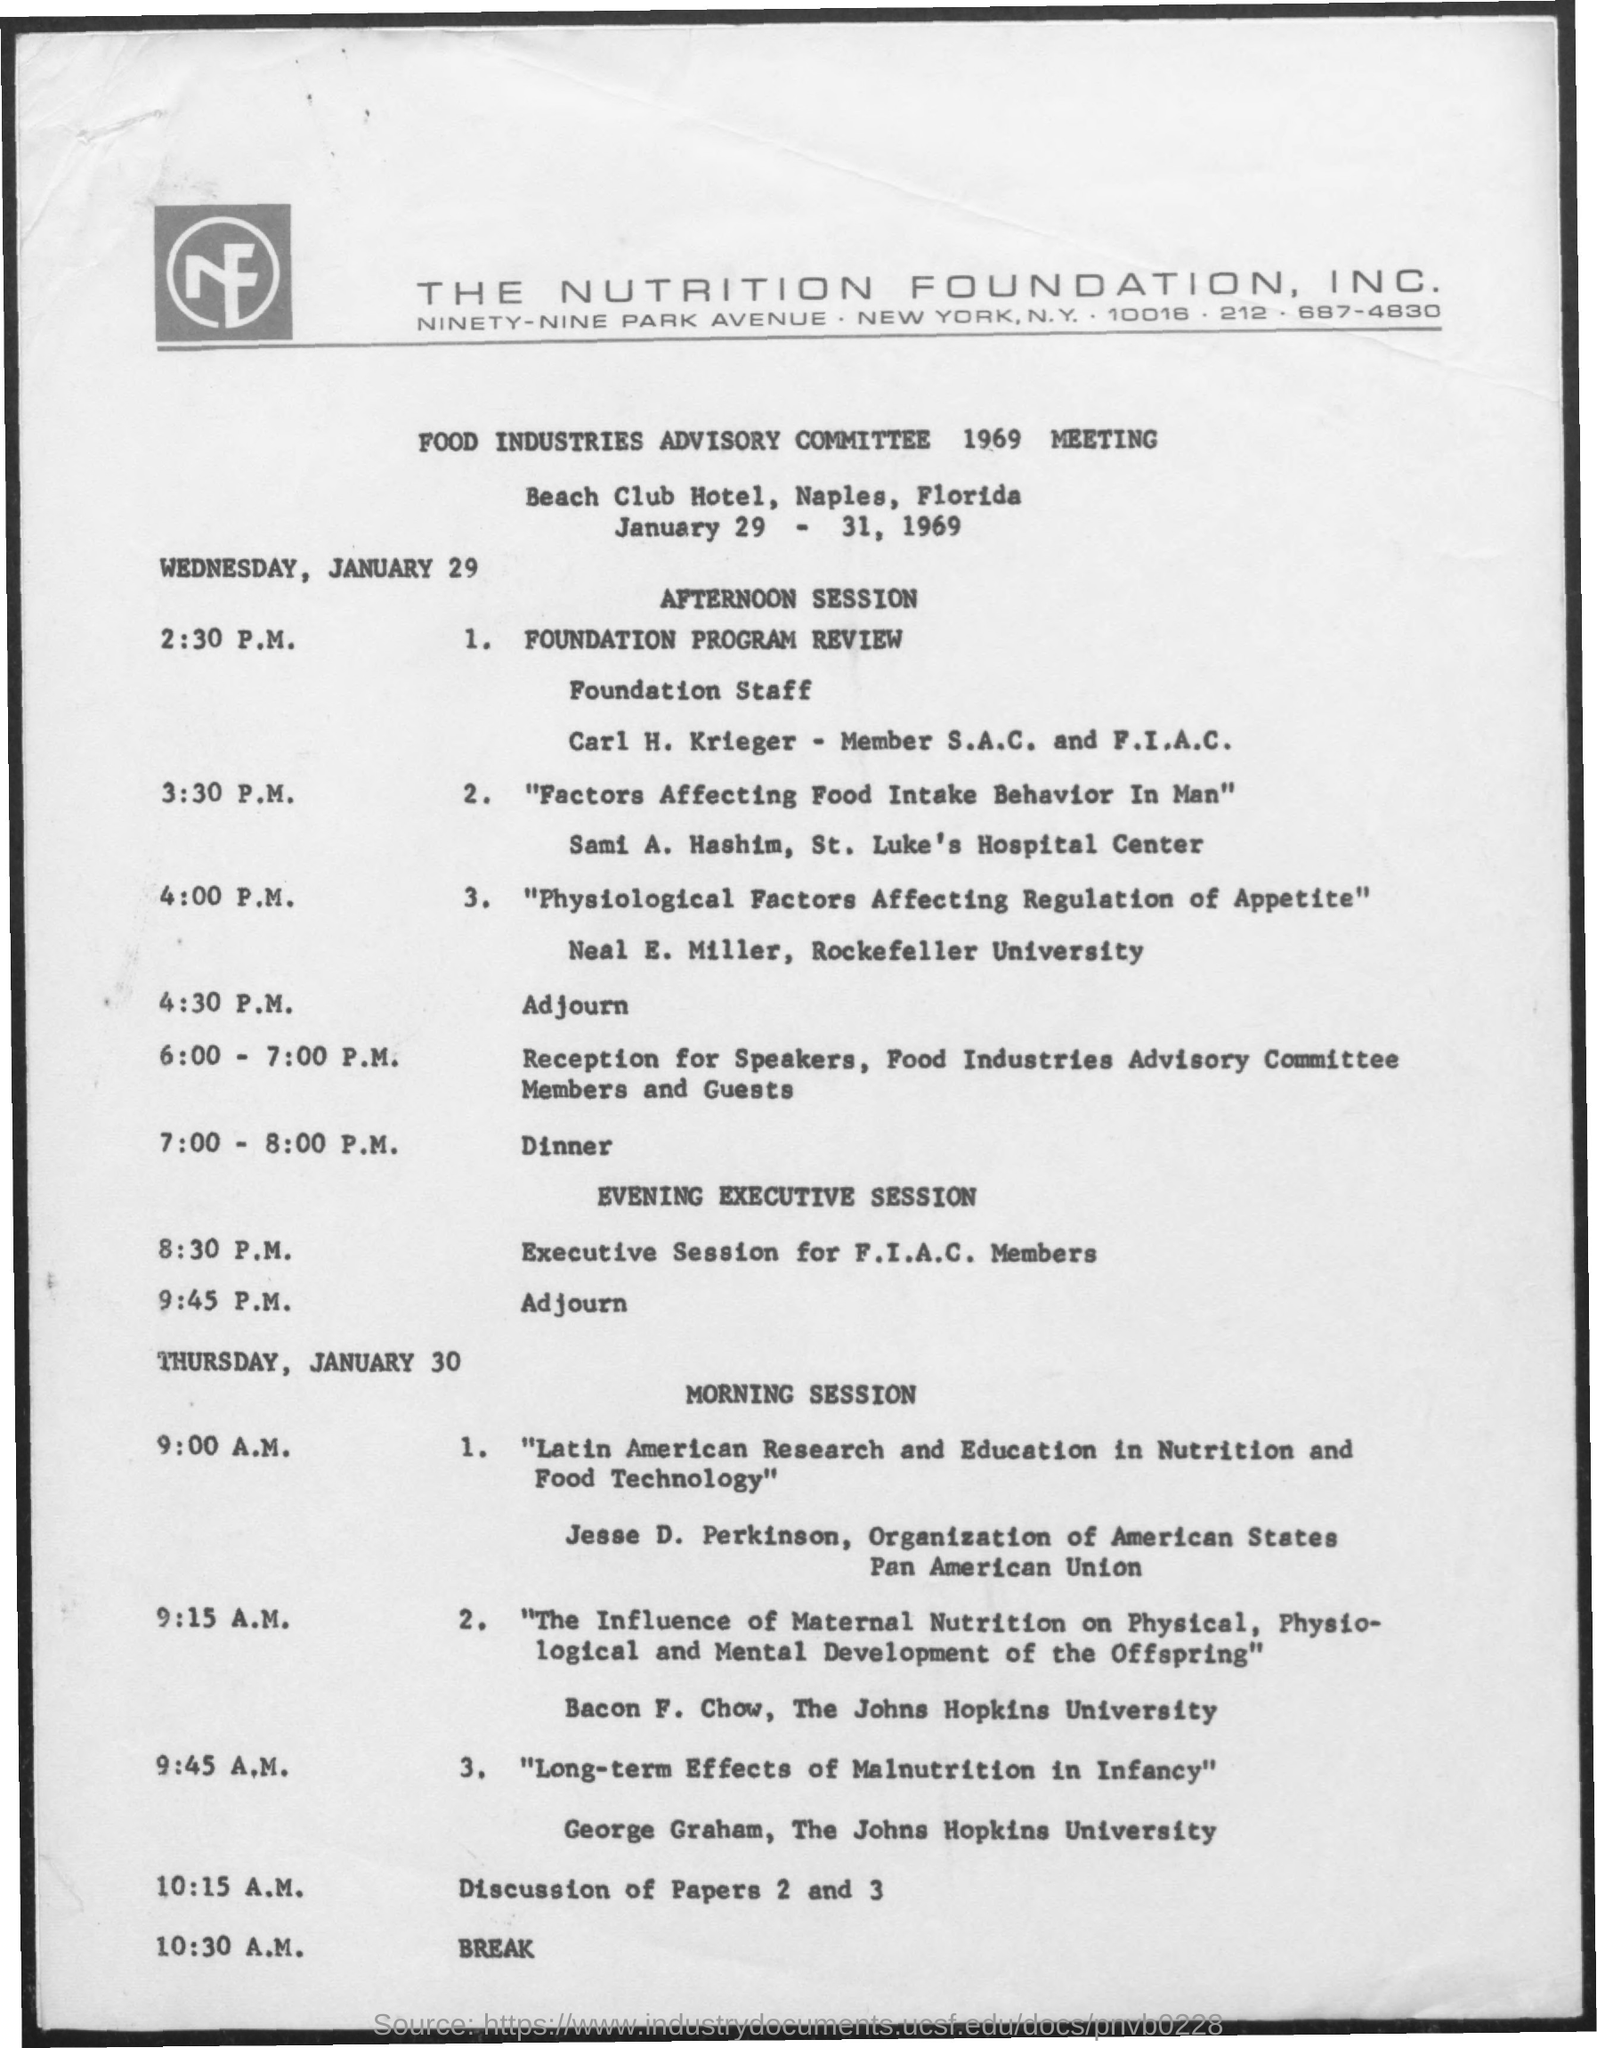In which city the nutrition foundation , inc located ?
Offer a terse response. New York. What is the break time on thursday , january 30
Provide a short and direct response. 10:30 A.M. What is the time for discussion of papers 2 and 3
Ensure brevity in your answer.  10:15 A.M . What is the name of the hotel mentioned ?
Make the answer very short. Beach club hotel. In which  state and city beach club hotel is located ?
Offer a very short reply. Naples, Florida. 